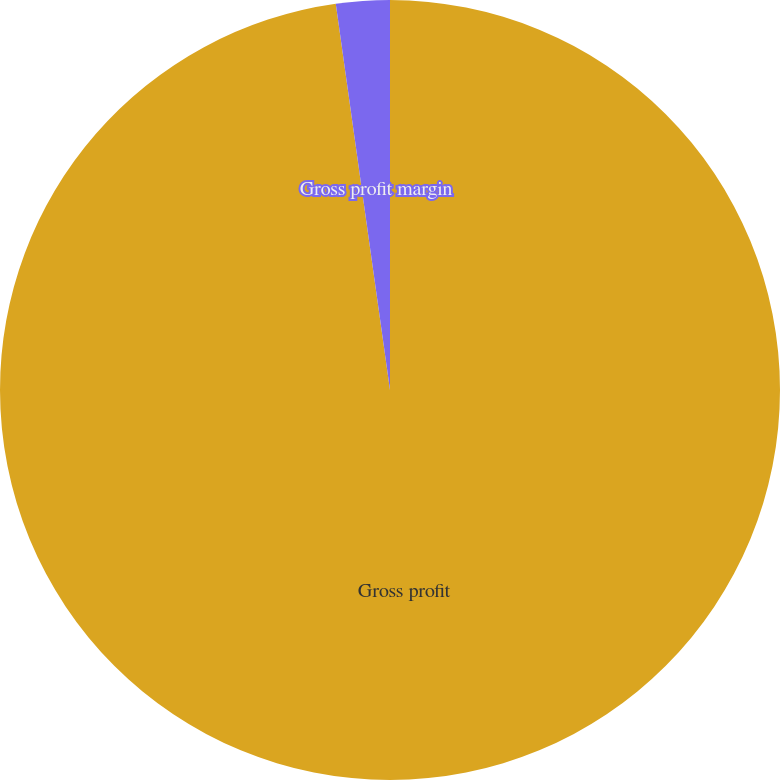Convert chart. <chart><loc_0><loc_0><loc_500><loc_500><pie_chart><fcel>Gross profit<fcel>Gross profit margin<nl><fcel>97.78%<fcel>2.22%<nl></chart> 